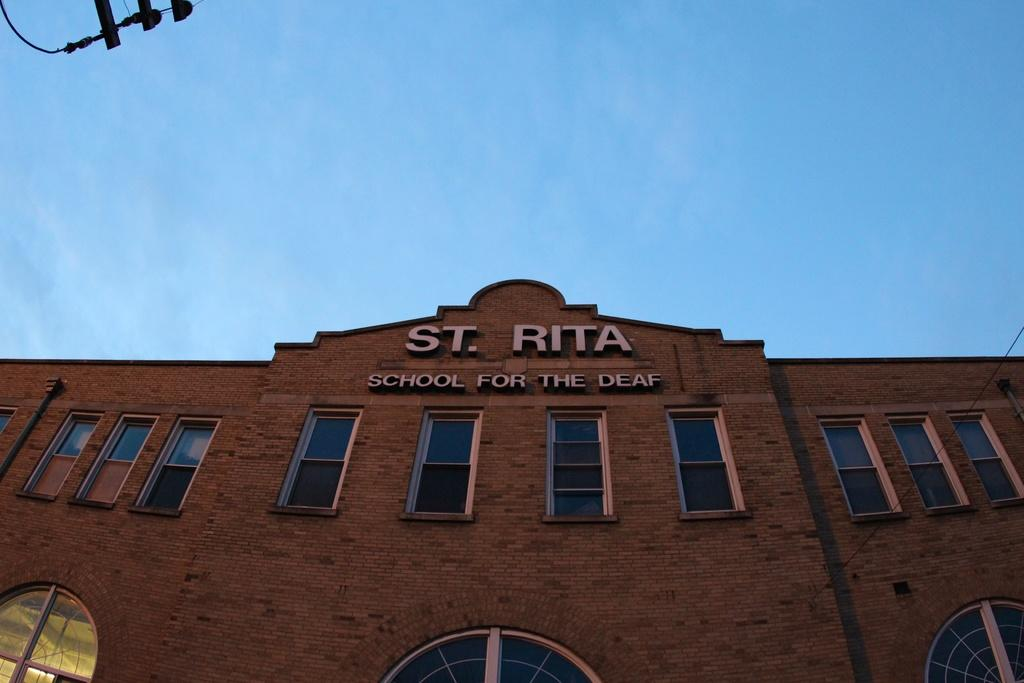What type of structure is visible in the image? There is a building in the image. What is written on the building? The building has "St. Rita School for the Deaf" written on it. Can you describe the object in the left top corner of the image? Unfortunately, the provided facts do not give any information about the object in the left top corner of the image. Who is the owner of the mask in the image? There is no mask present in the image, so it is not possible to determine the owner. 